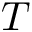Convert formula to latex. <formula><loc_0><loc_0><loc_500><loc_500>T</formula> 